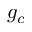<formula> <loc_0><loc_0><loc_500><loc_500>g _ { c }</formula> 